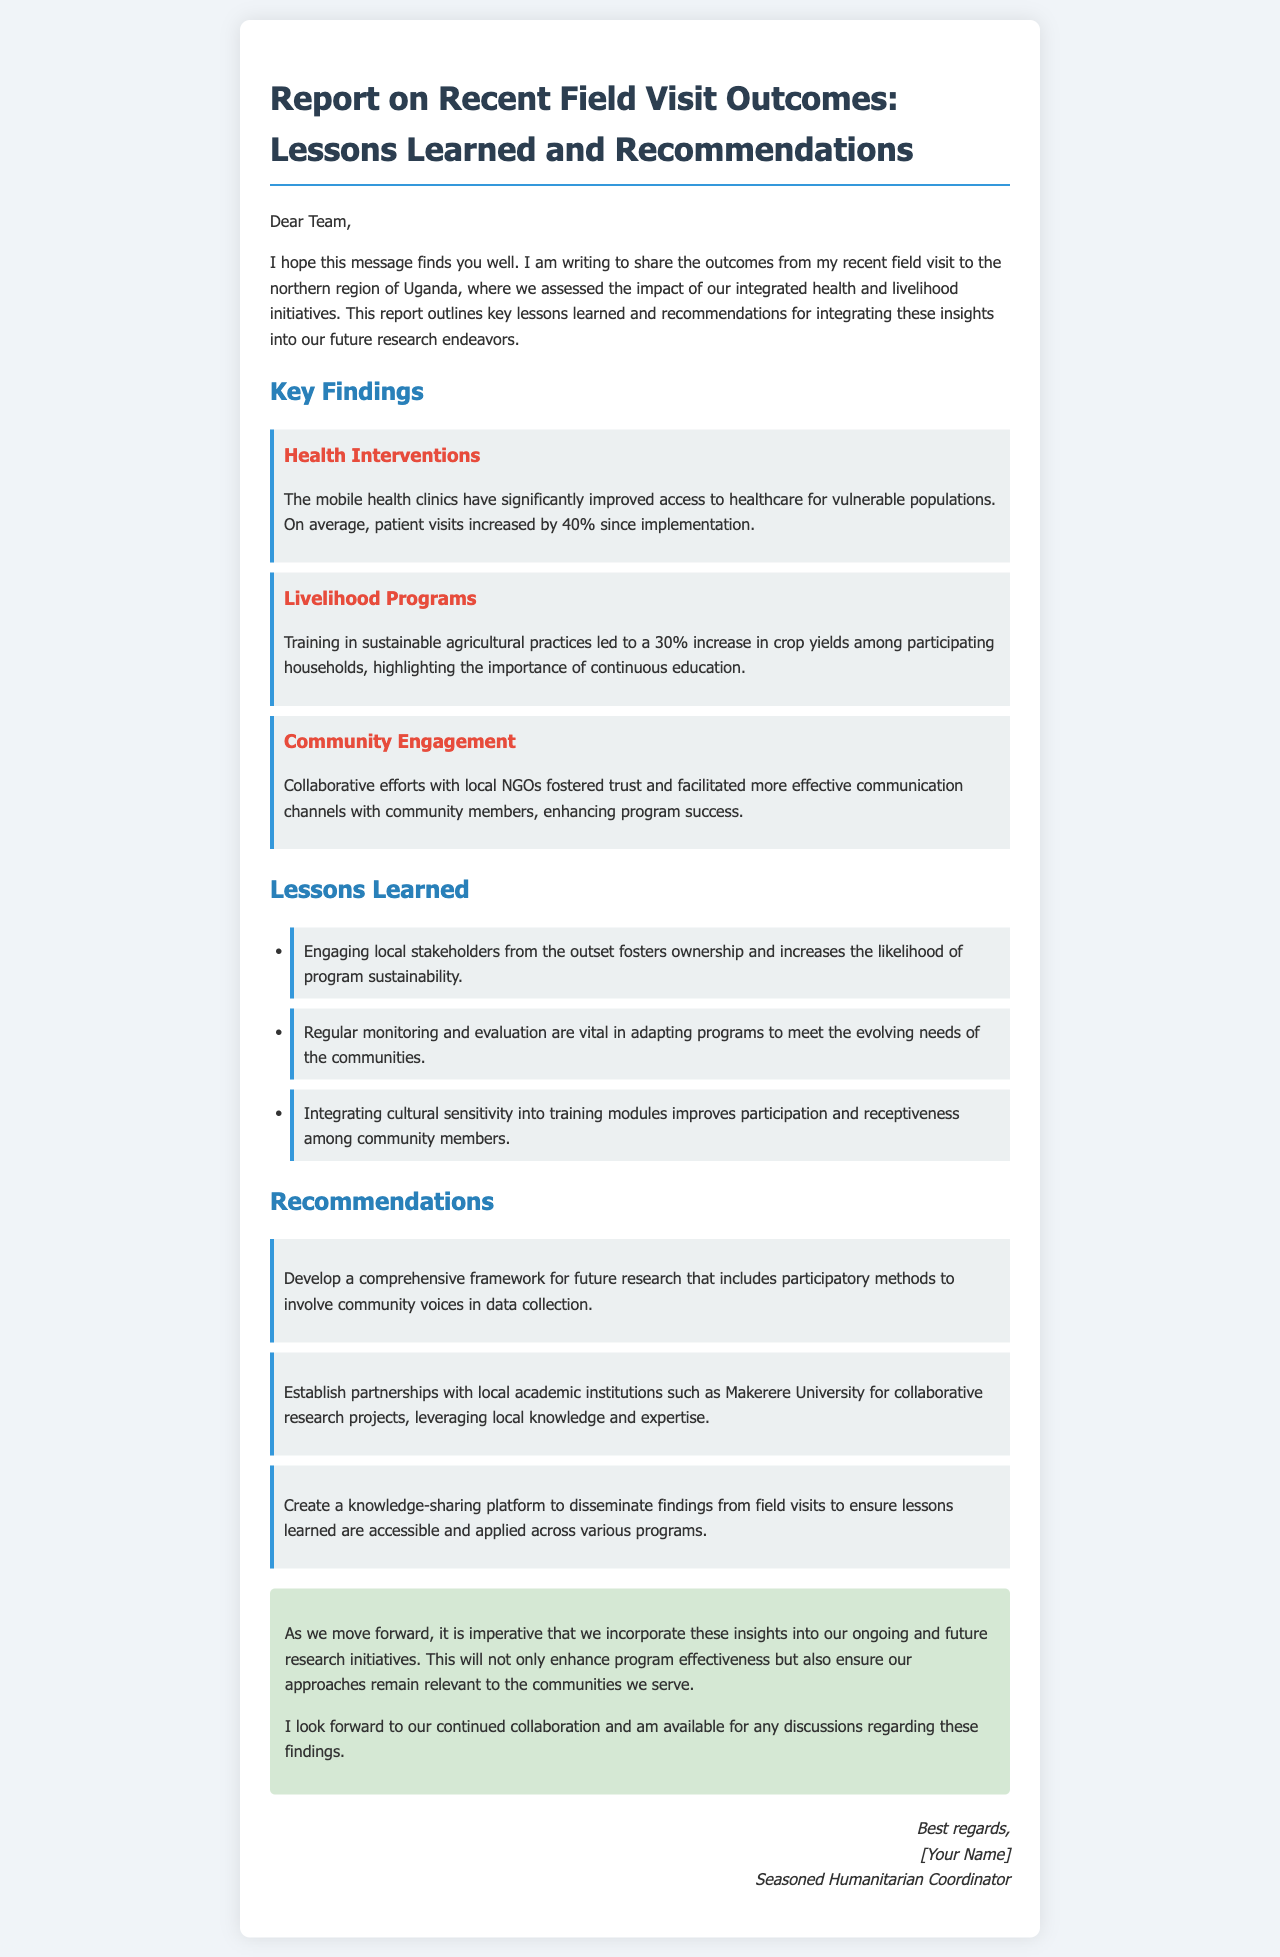What is the purpose of the report? The report aims to share the outcomes from a field visit and outline key lessons learned and recommendations for future research endeavors.
Answer: share outcomes Where was the field visit conducted? The field visit was conducted in the northern region of Uganda.
Answer: northern region of Uganda By what percentage did patient visits increase due to health interventions? Patient visits increased by 40% since the implementation of mobile health clinics.
Answer: 40% What was the increase in crop yields among participating households? Training in sustainable agricultural practices led to a 30% increase in crop yields.
Answer: 30% What is one lesson learned regarding stakeholder engagement? Engaging local stakeholders from the outset fosters ownership and increases program sustainability.
Answer: ownership What is one recommendation for future research? Develop a comprehensive framework for future research that includes participatory methods.
Answer: comprehensive framework Which institution was suggested for partnerships in collaborative research projects? Makerere University was suggested for partnerships with local academic institutions.
Answer: Makerere University What impact did community engagement have on program success? Collaborative efforts with local NGOs fostered trust and facilitated more effective communication channels.
Answer: fostered trust What type of platform should be created according to the recommendations? A knowledge-sharing platform should be created to disseminate findings from field visits.
Answer: knowledge-sharing platform 